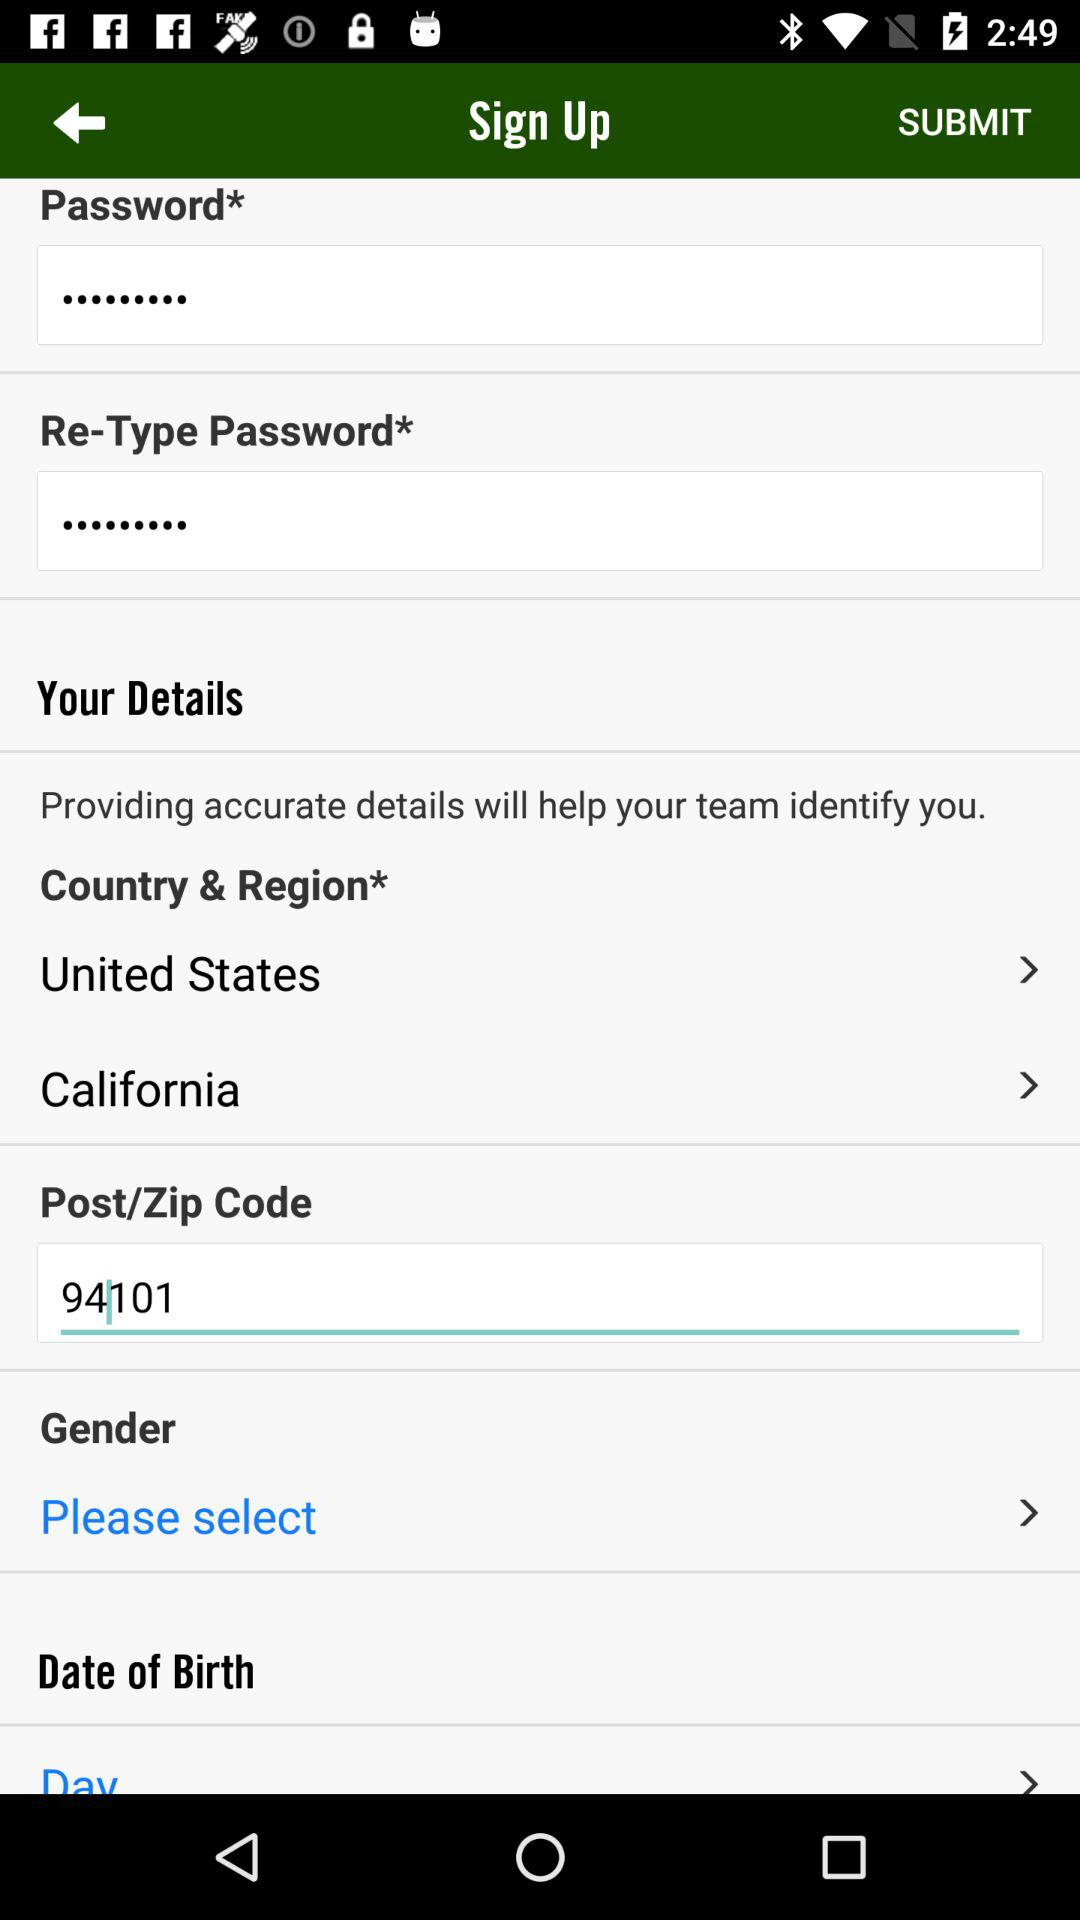What is the selected state? The state is "California". 